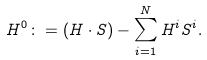Convert formula to latex. <formula><loc_0><loc_0><loc_500><loc_500>H ^ { 0 } \colon = ( H \cdot S ) - \sum _ { i = 1 } ^ { N } H ^ { i } S ^ { i } .</formula> 